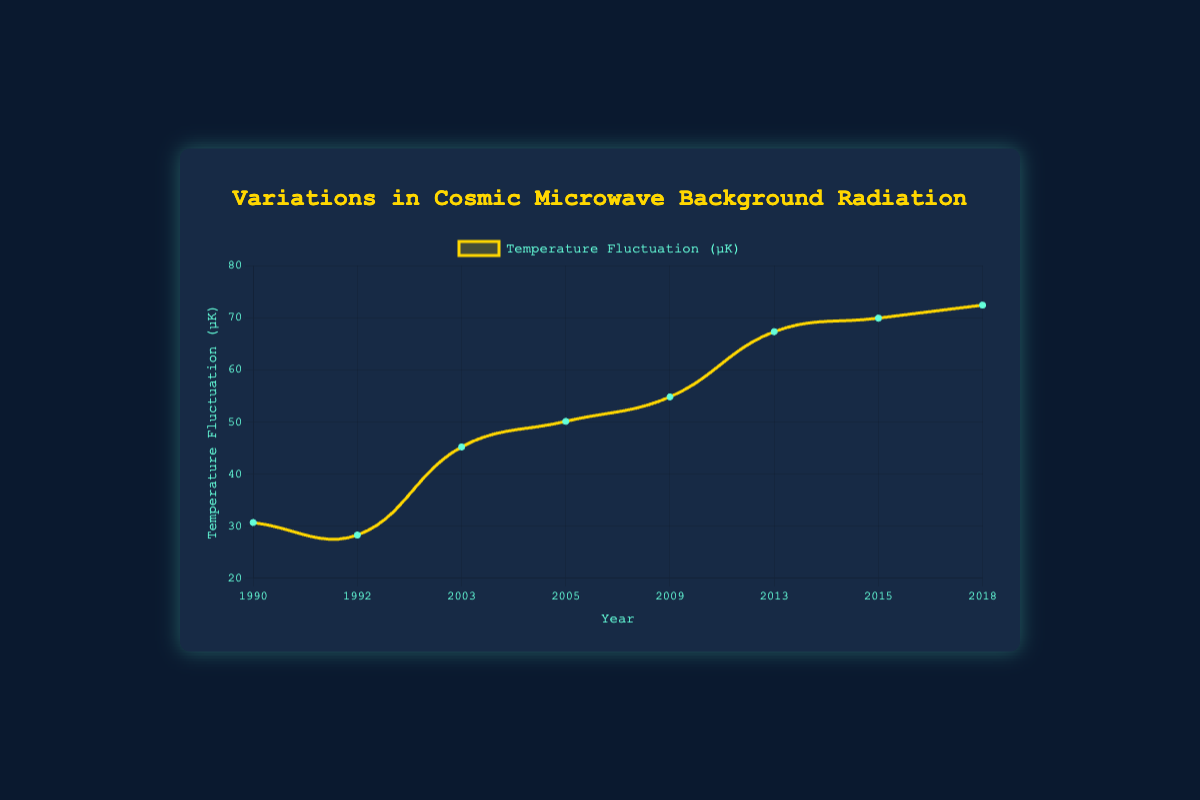What's the highest temperature fluctuation recorded in the data? The highest peak on the chart corresponds to the year 2018, with a temperature fluctuation of 72.4 µK.
Answer: 72.4 µK What is the overall trend in temperature fluctuation from 1990 to 2018? Observing the plot, there's a generally increasing trend in temperature fluctuations over time, especially from 2003 onwards.
Answer: Increasing How much did the temperature fluctuation increase between 1992 and 2003? The temperature fluctuation in 1992 was 28.3 µK, and in 2003 it was 45.2 µK. The increase is 45.2 - 28.3 = 16.9 µK.
Answer: 16.9 µK Which mission recorded the largest single-year increase in temperature fluctuation? By observing the plot, the largest single-year increase is between 2009 (54.8 µK) and 2013 (67.3 µK), an increase of 67.3 - 54.8 = 12.5 µK, recorded by the Planck mission.
Answer: Planck Mission Compare the temperature fluctuations recorded by the WMAP and Planck missions. Which had higher values overall? The Planck mission consistently recorded higher temperature fluctuations (67.3 - 72.4 µK) compared to the WMAP mission (45.2 - 54.8 µK).
Answer: Planck Mission What was the average temperature fluctuation during the WMAP mission years? The WMAP mission years and fluctuations are: 2003 (45.2 µK), 2005 (50.1 µK), and 2009 (54.8 µK). Average = (45.2 + 50.1 + 54.8) / 3 ≈ 50.03 µK.
Answer: 50.03 µK Identify any year where the temperature fluctuation decreased compared to the previous recorded year. In 1992, the temperature fluctuation (28.3 µK) is lower than in 1990 (30.7 µK).
Answer: 1992 How does the dataset visually represent the significance of different missions? The chart uses different colors for each point and labels to denote different missions, with colors like gold for the line and teal for points, making it easy to differentiate between periods.
Answer: Color differentiation Calculate the difference in temperature fluctuation between the first and last recorded years on the plot. The fluctuation in 1990 is 30.7 µK, and in 2018 it is 72.4 µK. Difference = 72.4 - 30.7 = 41.7 µK.
Answer: 41.7 µK 